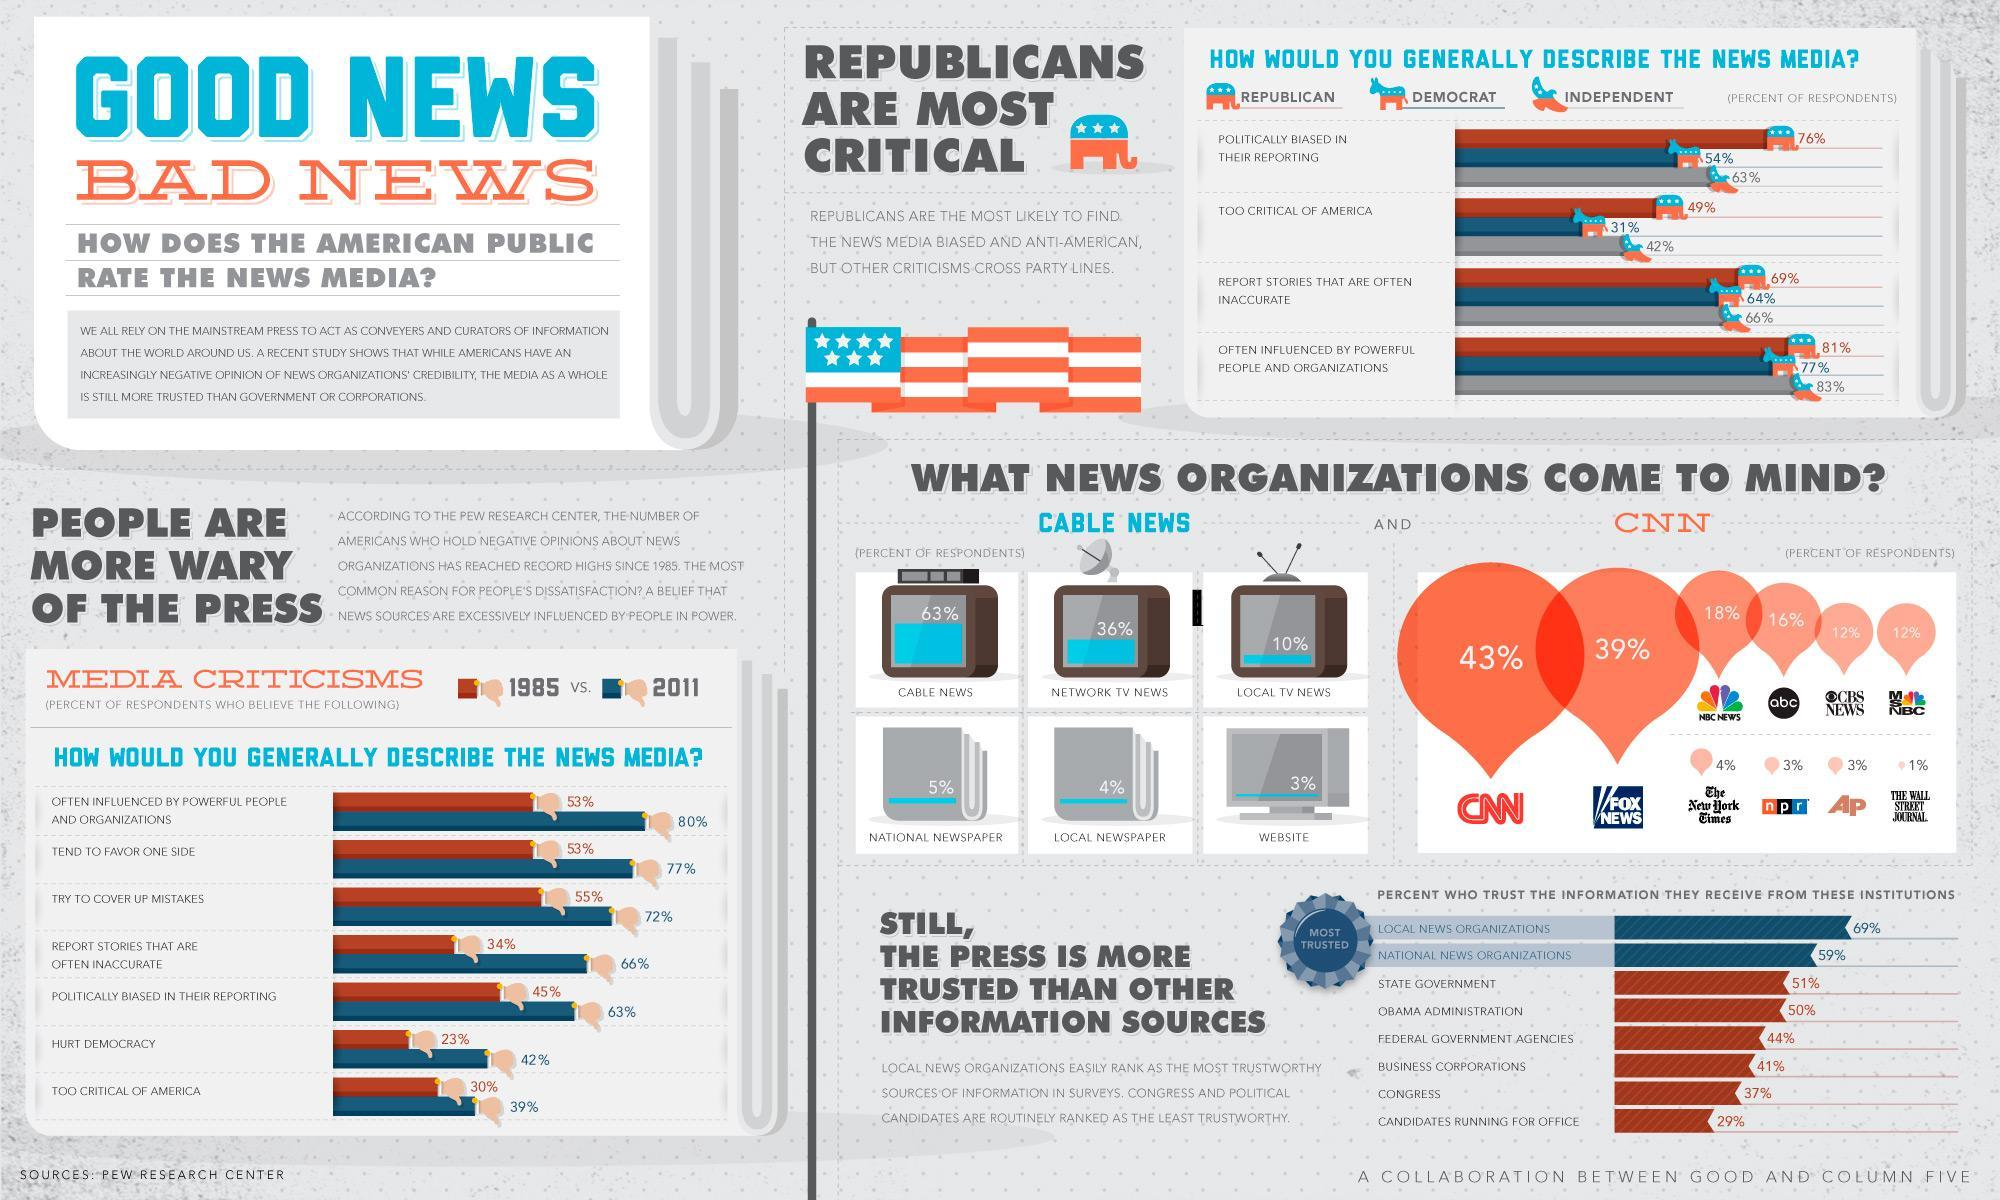Which is the third most trusted organization?
Answer the question with a short phrase. State Government 